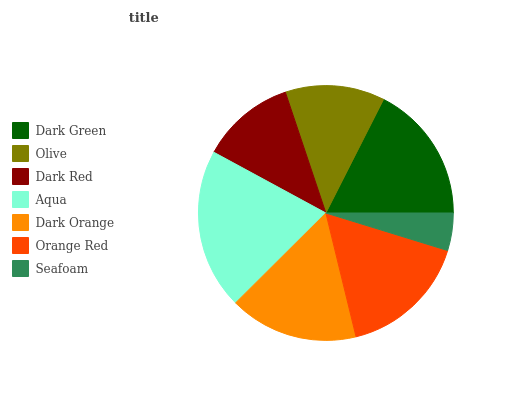Is Seafoam the minimum?
Answer yes or no. Yes. Is Aqua the maximum?
Answer yes or no. Yes. Is Olive the minimum?
Answer yes or no. No. Is Olive the maximum?
Answer yes or no. No. Is Dark Green greater than Olive?
Answer yes or no. Yes. Is Olive less than Dark Green?
Answer yes or no. Yes. Is Olive greater than Dark Green?
Answer yes or no. No. Is Dark Green less than Olive?
Answer yes or no. No. Is Dark Orange the high median?
Answer yes or no. Yes. Is Dark Orange the low median?
Answer yes or no. Yes. Is Aqua the high median?
Answer yes or no. No. Is Dark Red the low median?
Answer yes or no. No. 